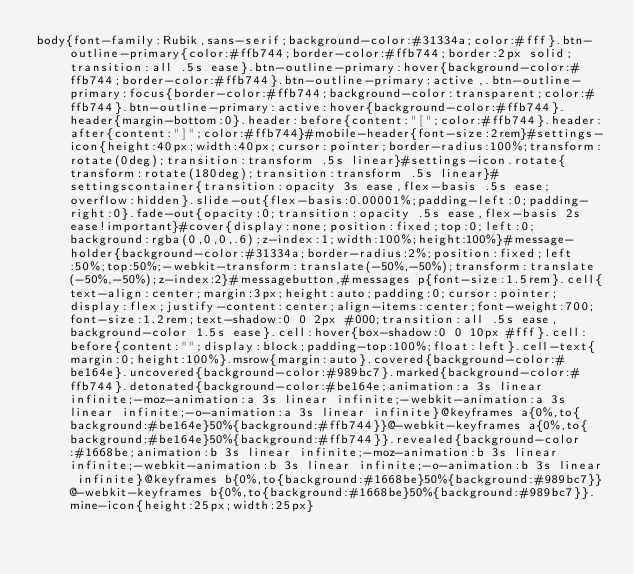Convert code to text. <code><loc_0><loc_0><loc_500><loc_500><_CSS_>body{font-family:Rubik,sans-serif;background-color:#31334a;color:#fff}.btn-outline-primary{color:#ffb744;border-color:#ffb744;border:2px solid;transition:all .5s ease}.btn-outline-primary:hover{background-color:#ffb744;border-color:#ffb744}.btn-outline-primary:active,.btn-outline-primary:focus{border-color:#ffb744;background-color:transparent;color:#ffb744}.btn-outline-primary:active:hover{background-color:#ffb744}.header{margin-bottom:0}.header:before{content:"[";color:#ffb744}.header:after{content:"]";color:#ffb744}#mobile-header{font-size:2rem}#settings-icon{height:40px;width:40px;cursor:pointer;border-radius:100%;transform:rotate(0deg);transition:transform .5s linear}#settings-icon.rotate{transform:rotate(180deg);transition:transform .5s linear}#settingscontainer{transition:opacity 3s ease,flex-basis .5s ease;overflow:hidden}.slide-out{flex-basis:0.00001%;padding-left:0;padding-right:0}.fade-out{opacity:0;transition:opacity .5s ease,flex-basis 2s ease!important}#cover{display:none;position:fixed;top:0;left:0;background:rgba(0,0,0,.6);z-index:1;width:100%;height:100%}#message-holder{background-color:#31334a;border-radius:2%;position:fixed;left:50%;top:50%;-webkit-transform:translate(-50%,-50%);transform:translate(-50%,-50%);z-index:2}#messagebutton,#messages p{font-size:1.5rem}.cell{text-align:center;margin:3px;height:auto;padding:0;cursor:pointer;display:flex;justify-content:center;align-items:center;font-weight:700;font-size:1.2rem;text-shadow:0 0 2px #000;transition:all .5s ease,background-color 1.5s ease}.cell:hover{box-shadow:0 0 10px #fff}.cell:before{content:"";display:block;padding-top:100%;float:left}.cell-text{margin:0;height:100%}.msrow{margin:auto}.covered{background-color:#be164e}.uncovered{background-color:#989bc7}.marked{background-color:#ffb744}.detonated{background-color:#be164e;animation:a 3s linear infinite;-moz-animation:a 3s linear infinite;-webkit-animation:a 3s linear infinite;-o-animation:a 3s linear infinite}@keyframes a{0%,to{background:#be164e}50%{background:#ffb744}}@-webkit-keyframes a{0%,to{background:#be164e}50%{background:#ffb744}}.revealed{background-color:#1668be;animation:b 3s linear infinite;-moz-animation:b 3s linear infinite;-webkit-animation:b 3s linear infinite;-o-animation:b 3s linear infinite}@keyframes b{0%,to{background:#1668be}50%{background:#989bc7}}@-webkit-keyframes b{0%,to{background:#1668be}50%{background:#989bc7}}.mine-icon{height:25px;width:25px}</code> 